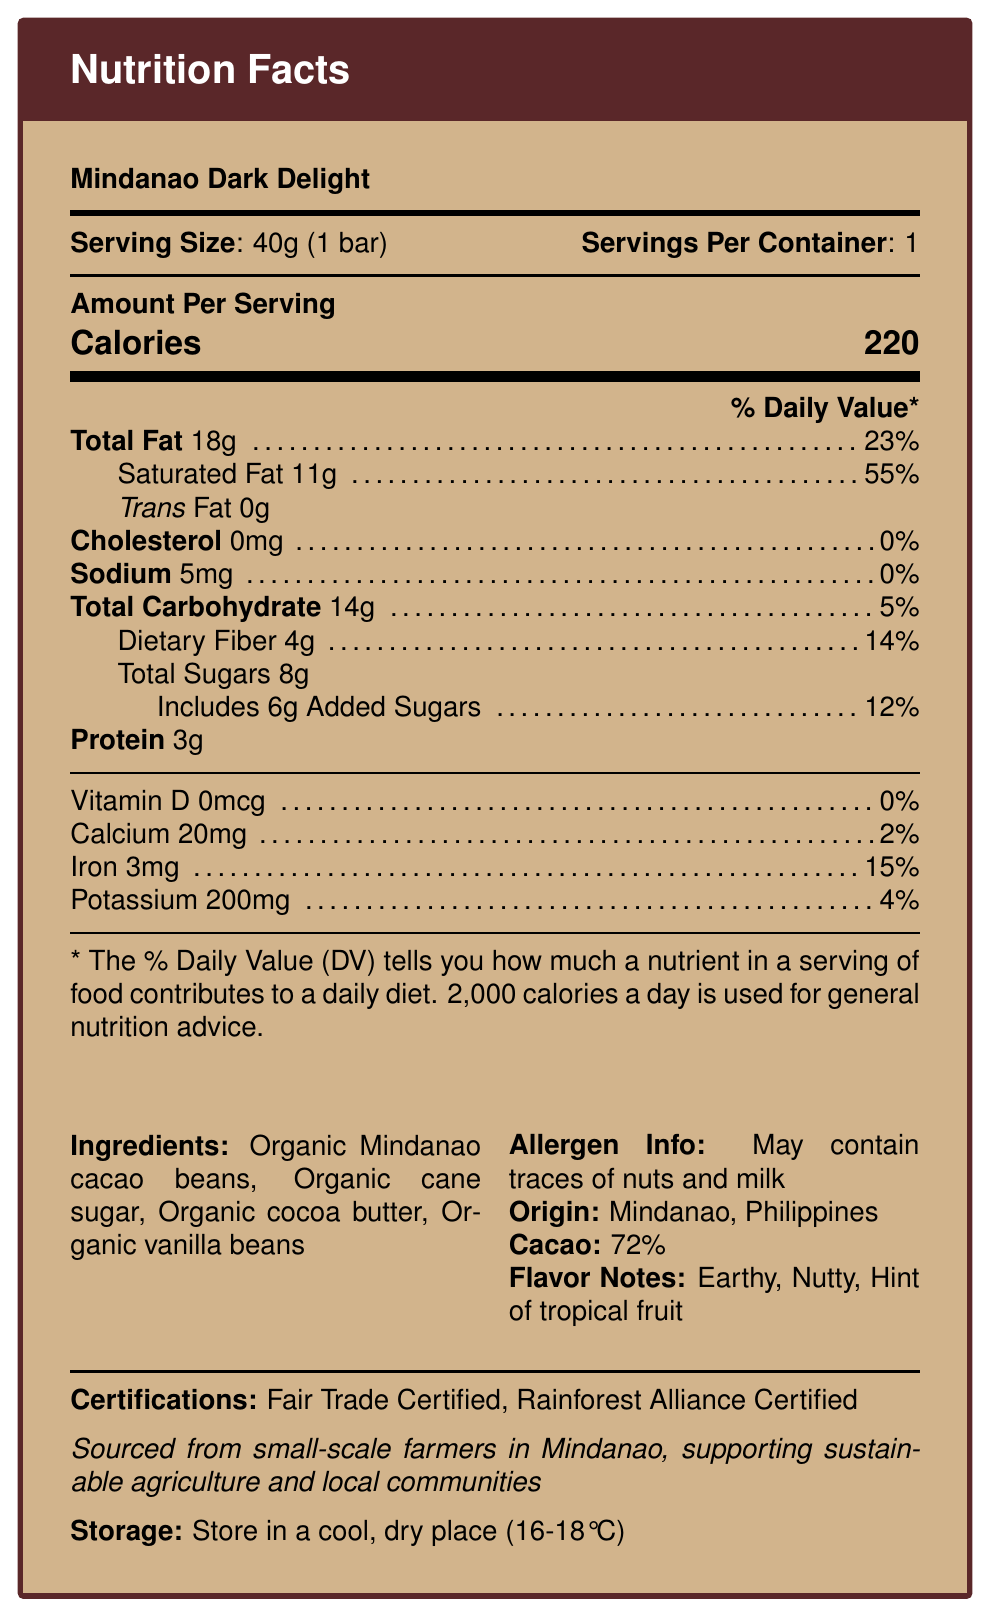What is the serving size of the Mindanao Dark Delight chocolate bar? The serving size is explicitly stated as "40g (1 bar)" in the document.
Answer: 40g (1 bar) How many calories are in one serving of Mindanao Dark Delight? The document clearly lists the calorie content as 220 per serving.
Answer: 220 What percentage of daily value for saturated fat does one serving provide? According to the nutrition facts, one serving contains 11g of saturated fat, which is 55% of the daily value.
Answer: 55% How many grams of dietary fiber are in the Mindanao Dark Delight chocolate bar? The document specifies that there are 4g of dietary fiber per serving.
Answer: 4g What is the total fat content per serving? The document lists "Total Fat" as 18g per serving.
Answer: 18g What are the flavor notes mentioned in the document? The flavor notes are described as "Earthy, Nutty, and Hint of tropical fruit" in the document.
Answer: Earthy, Nutty, Hint of tropical fruit Which of the following certifications does the Mindanao Dark Delight chocolate bar have? A. USDA Organic B. Fair Trade Certified C. Non-GMO Project Verified D. Rainforest Alliance Certified The document specifies that the chocolate bar is "Fair Trade Certified" and "Rainforest Alliance Certified."
Answer: B and D What is the origin of the cacao used in the Mindanao Dark Delight chocolate bar? A. Ecuador B. Ghana C. Mindanao, Philippines D. Madagascar The document states that the origin is "Mindanao, Philippines."
Answer: C Does the document mention any potential allergens? The allergen information listed in the document mentions that the product "May contain traces of nuts and milk."
Answer: Yes Summarize the information provided in the document. The document contains nutrition facts, ingredients, allergen information, flavor notes, origin, certifications, and a sustainability statement about the Mindanao Dark Delight chocolate bar.
Answer: The Mindanao Dark Delight chocolate bar is a single-origin dark chocolate with 72% cacao sourced from Mindanao, Philippines. It contains 220 calories per serving with 18g of total fat, 14g of total carbohydrates, and 3g of protein. It highlights flavor notes of earthy, nutty, and tropical fruit. Certifications include Fair Trade and Rainforest Alliance. The product is made with organic ingredients and supports sustainable agriculture. What is the storage instruction for the Mindanao Dark Delight chocolate bar? The document advises to "Store in a cool, dry place (16-18°C)."
Answer: Store in a cool, dry place (16-18°C) What percentage of the daily value of iron does the chocolate bar provide? The document indicates that one serving provides 15% of the daily value for iron.
Answer: 15% How much sodium is in one serving of the Mindanao Dark Delight chocolate bar? The document states that there is 5mg of sodium per serving.
Answer: 5mg What is the percentage of cacao in the Mindanao Dark Delight chocolate bar? The document specifies that the chocolate bar has 72% cacao content.
Answer: 72% Are there any vitamins listed in the nutrition facts? The document shows that there are 0mcg of Vitamin D, contributing 0% to the daily value, which means no significant vitamin content is listed.
Answer: No What is the main purpose of the sustainability statement in the document? The sustainability statement emphasizes the ethical sourcing and positive impact on local communities.
Answer: To highlight that the ingredients are sourced from small-scale farmers in Mindanao, supporting sustainable agriculture and local communities What is the total sugars content per serving? The document specifies that there are 8g of total sugars per serving, including 6g of added sugars.
Answer: 8g How many milligrams of calcium are there in the chocolate bar? The document states that one serving contains 20mg of calcium.
Answer: 20mg What type of beans are the main ingredient in the Mindanao Dark Delight chocolate bar? The ingredients list in the document includes "Organic Mindanao cacao beans."
Answer: Organic Mindanao cacao beans Is the chocolate bar gluten-free? The document does not provide information regarding gluten content.
Answer: Cannot be determined What are the ingredients of the Mindanao Dark Delight chocolate bar? The ingredients are listed as "Organic Mindanao cacao beans, Organic cane sugar, Organic cocoa butter, Organic vanilla beans" in the document.
Answer: Organic Mindanao cacao beans, Organic cane sugar, Organic cocoa butter, Organic vanilla beans 